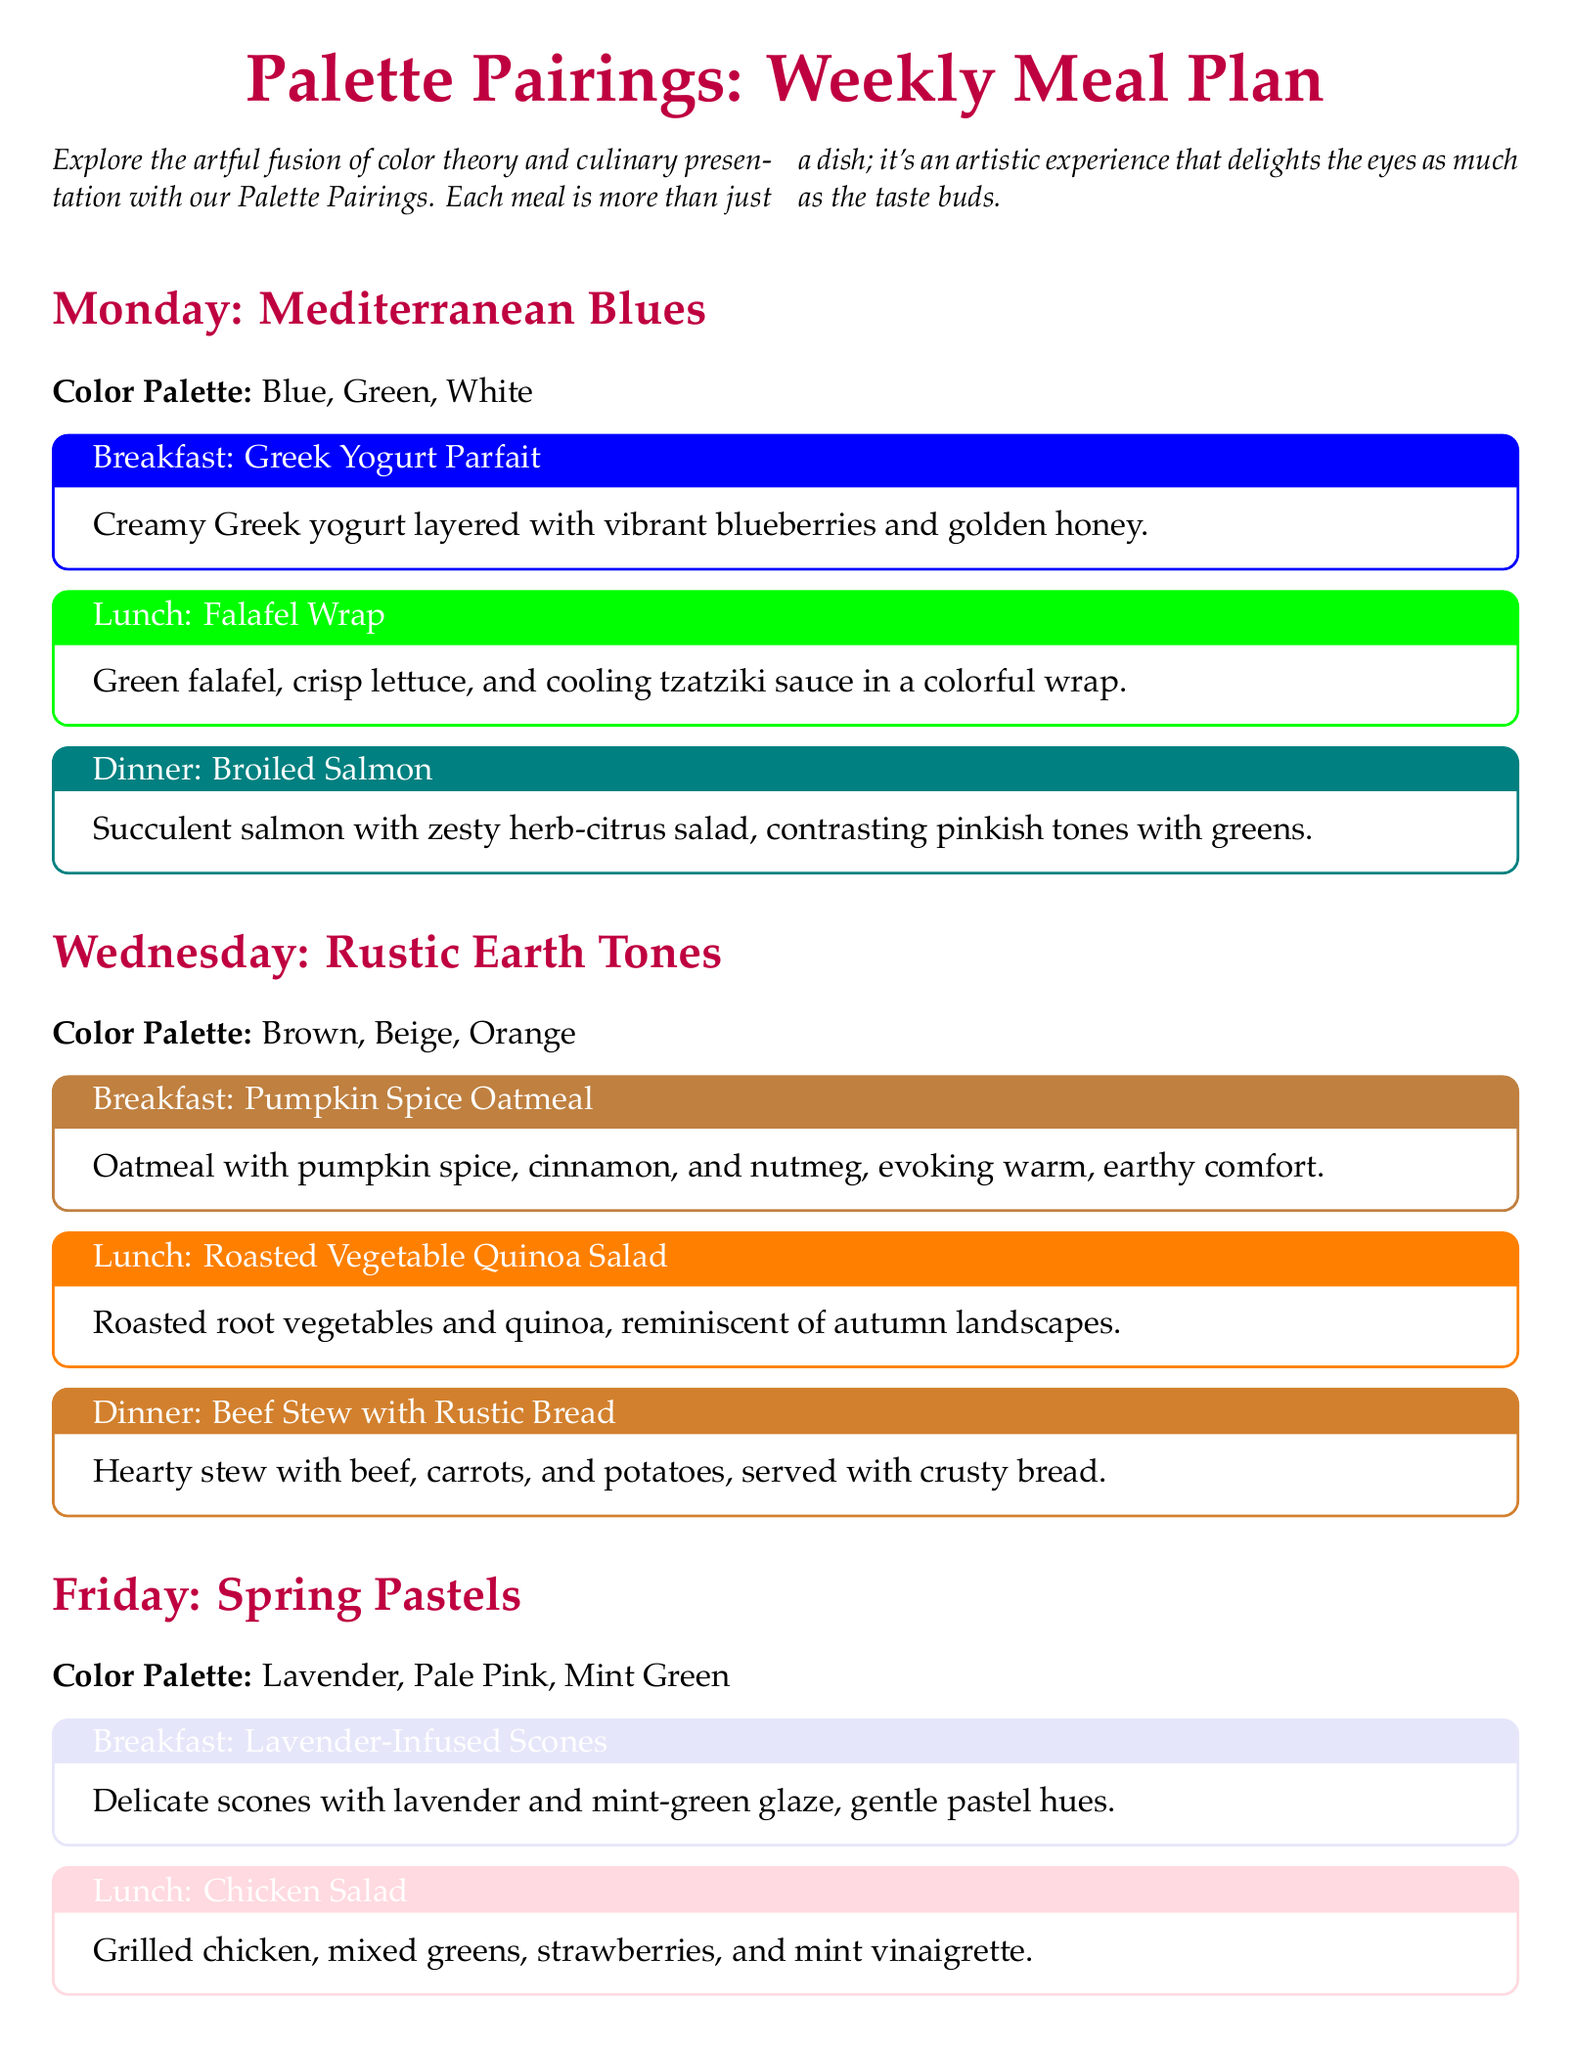What is the color palette for Monday? The color palette for Monday is Blue, Green, White.
Answer: Blue, Green, White What dish is served for lunch on Friday? The lunch dish for Friday is Chicken Salad.
Answer: Chicken Salad What ingredient is highlighted in the Pistachio-Crusted Chicken? The main ingredient highlighted is pistachios.
Answer: Pistachios How many meals are listed for Wednesday? There are three meals listed for Wednesday.
Answer: Three What color evokes calm at the start of the week? Blue and white evoke calm for the week's start.
Answer: Blue and white Which dish features lavender in its presentation? The dish featuring lavender is Lavender-Infused Scones.
Answer: Lavender-Infused Scones What type of meal does the document focus on? The document focuses on a meal plan.
Answer: Meal plan How does the document categorize each day’s dishes? Each day's dishes are categorized by color palettes.
Answer: Color palettes What is noted about the color palette used on Friday? The color palette on Friday is described as pastels.
Answer: Pastels 